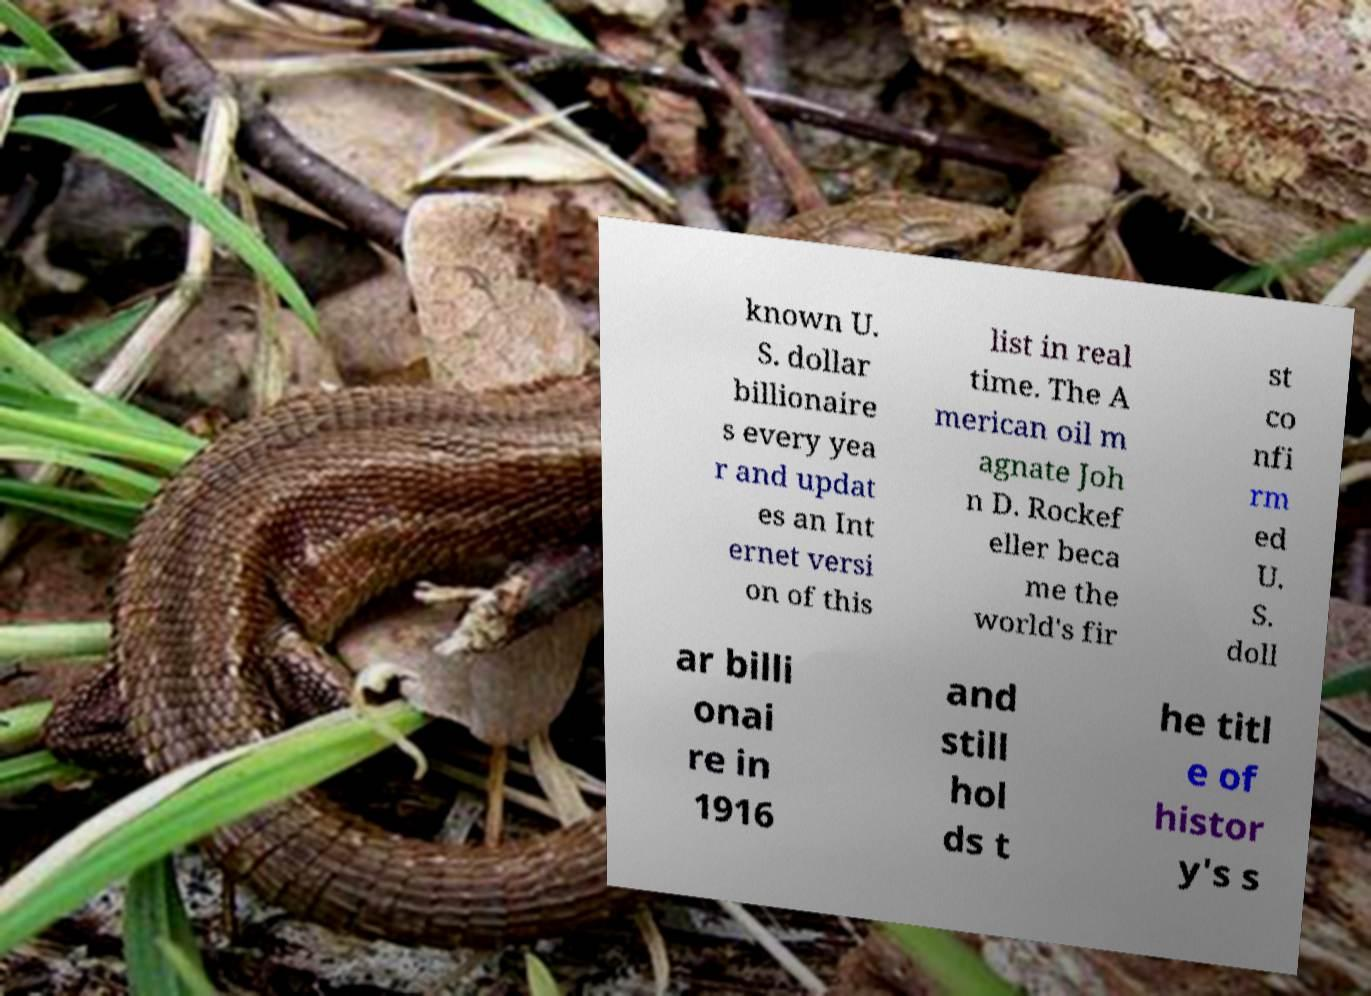Please identify and transcribe the text found in this image. known U. S. dollar billionaire s every yea r and updat es an Int ernet versi on of this list in real time. The A merican oil m agnate Joh n D. Rockef eller beca me the world's fir st co nfi rm ed U. S. doll ar billi onai re in 1916 and still hol ds t he titl e of histor y's s 